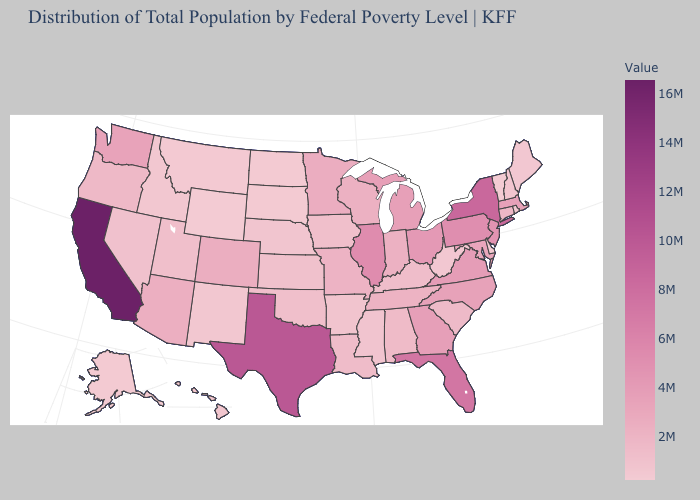Does Illinois have the highest value in the MidWest?
Keep it brief. Yes. Does the map have missing data?
Be succinct. No. Among the states that border Ohio , does Pennsylvania have the highest value?
Be succinct. Yes. Which states have the lowest value in the South?
Quick response, please. Delaware. Does Wyoming have the lowest value in the USA?
Concise answer only. Yes. Which states hav the highest value in the MidWest?
Answer briefly. Illinois. 